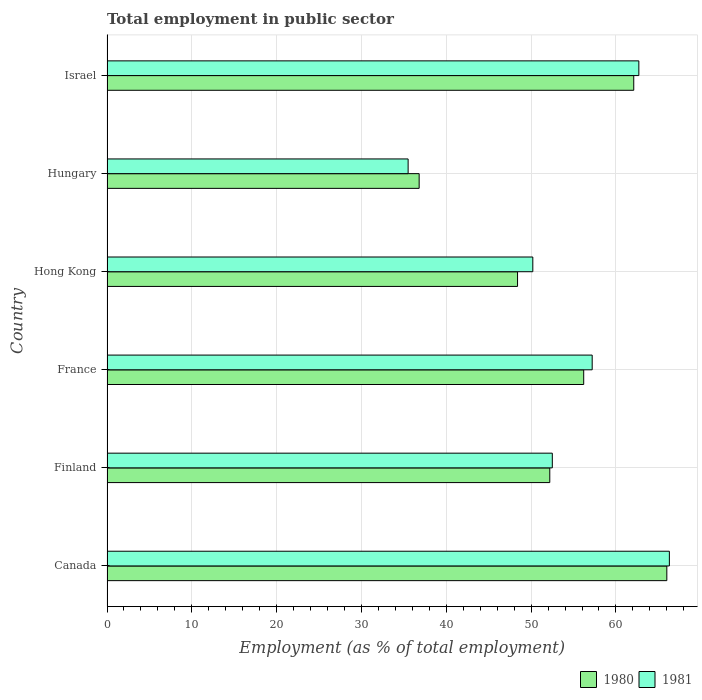How many groups of bars are there?
Provide a short and direct response. 6. How many bars are there on the 4th tick from the top?
Provide a short and direct response. 2. What is the label of the 4th group of bars from the top?
Give a very brief answer. France. What is the employment in public sector in 1980 in Hungary?
Your answer should be compact. 36.8. Across all countries, what is the maximum employment in public sector in 1981?
Keep it short and to the point. 66.3. Across all countries, what is the minimum employment in public sector in 1981?
Provide a succinct answer. 35.5. In which country was the employment in public sector in 1981 minimum?
Your response must be concise. Hungary. What is the total employment in public sector in 1980 in the graph?
Make the answer very short. 321.7. What is the difference between the employment in public sector in 1980 in Canada and that in Hong Kong?
Give a very brief answer. 17.6. What is the difference between the employment in public sector in 1981 in Finland and the employment in public sector in 1980 in Israel?
Make the answer very short. -9.6. What is the average employment in public sector in 1981 per country?
Your answer should be compact. 54.07. What is the difference between the employment in public sector in 1980 and employment in public sector in 1981 in Israel?
Your response must be concise. -0.6. In how many countries, is the employment in public sector in 1980 greater than 50 %?
Provide a succinct answer. 4. What is the ratio of the employment in public sector in 1980 in France to that in Israel?
Your answer should be very brief. 0.9. Is the difference between the employment in public sector in 1980 in Canada and Hungary greater than the difference between the employment in public sector in 1981 in Canada and Hungary?
Offer a terse response. No. What is the difference between the highest and the second highest employment in public sector in 1981?
Your answer should be compact. 3.6. What is the difference between the highest and the lowest employment in public sector in 1980?
Your response must be concise. 29.2. How many bars are there?
Provide a succinct answer. 12. How many countries are there in the graph?
Provide a succinct answer. 6. What is the difference between two consecutive major ticks on the X-axis?
Your answer should be compact. 10. Does the graph contain any zero values?
Your answer should be compact. No. Where does the legend appear in the graph?
Your answer should be very brief. Bottom right. What is the title of the graph?
Provide a short and direct response. Total employment in public sector. Does "1965" appear as one of the legend labels in the graph?
Your answer should be compact. No. What is the label or title of the X-axis?
Your response must be concise. Employment (as % of total employment). What is the label or title of the Y-axis?
Keep it short and to the point. Country. What is the Employment (as % of total employment) in 1981 in Canada?
Give a very brief answer. 66.3. What is the Employment (as % of total employment) in 1980 in Finland?
Provide a succinct answer. 52.2. What is the Employment (as % of total employment) in 1981 in Finland?
Keep it short and to the point. 52.5. What is the Employment (as % of total employment) of 1980 in France?
Make the answer very short. 56.2. What is the Employment (as % of total employment) of 1981 in France?
Offer a very short reply. 57.2. What is the Employment (as % of total employment) in 1980 in Hong Kong?
Offer a very short reply. 48.4. What is the Employment (as % of total employment) in 1981 in Hong Kong?
Ensure brevity in your answer.  50.2. What is the Employment (as % of total employment) of 1980 in Hungary?
Keep it short and to the point. 36.8. What is the Employment (as % of total employment) of 1981 in Hungary?
Your answer should be very brief. 35.5. What is the Employment (as % of total employment) in 1980 in Israel?
Provide a short and direct response. 62.1. What is the Employment (as % of total employment) in 1981 in Israel?
Provide a short and direct response. 62.7. Across all countries, what is the maximum Employment (as % of total employment) of 1981?
Your response must be concise. 66.3. Across all countries, what is the minimum Employment (as % of total employment) of 1980?
Make the answer very short. 36.8. Across all countries, what is the minimum Employment (as % of total employment) of 1981?
Your answer should be compact. 35.5. What is the total Employment (as % of total employment) of 1980 in the graph?
Provide a succinct answer. 321.7. What is the total Employment (as % of total employment) in 1981 in the graph?
Offer a terse response. 324.4. What is the difference between the Employment (as % of total employment) in 1981 in Canada and that in Finland?
Provide a succinct answer. 13.8. What is the difference between the Employment (as % of total employment) of 1980 in Canada and that in France?
Provide a short and direct response. 9.8. What is the difference between the Employment (as % of total employment) in 1980 in Canada and that in Hungary?
Provide a succinct answer. 29.2. What is the difference between the Employment (as % of total employment) in 1981 in Canada and that in Hungary?
Your answer should be very brief. 30.8. What is the difference between the Employment (as % of total employment) of 1981 in Finland and that in France?
Give a very brief answer. -4.7. What is the difference between the Employment (as % of total employment) of 1980 in Finland and that in Hong Kong?
Make the answer very short. 3.8. What is the difference between the Employment (as % of total employment) of 1981 in Finland and that in Hungary?
Your response must be concise. 17. What is the difference between the Employment (as % of total employment) of 1981 in France and that in Hong Kong?
Offer a terse response. 7. What is the difference between the Employment (as % of total employment) of 1980 in France and that in Hungary?
Give a very brief answer. 19.4. What is the difference between the Employment (as % of total employment) of 1981 in France and that in Hungary?
Your answer should be very brief. 21.7. What is the difference between the Employment (as % of total employment) in 1980 in Hong Kong and that in Israel?
Ensure brevity in your answer.  -13.7. What is the difference between the Employment (as % of total employment) of 1980 in Hungary and that in Israel?
Offer a very short reply. -25.3. What is the difference between the Employment (as % of total employment) in 1981 in Hungary and that in Israel?
Your answer should be very brief. -27.2. What is the difference between the Employment (as % of total employment) of 1980 in Canada and the Employment (as % of total employment) of 1981 in Finland?
Provide a succinct answer. 13.5. What is the difference between the Employment (as % of total employment) of 1980 in Canada and the Employment (as % of total employment) of 1981 in Hong Kong?
Offer a terse response. 15.8. What is the difference between the Employment (as % of total employment) of 1980 in Canada and the Employment (as % of total employment) of 1981 in Hungary?
Offer a terse response. 30.5. What is the difference between the Employment (as % of total employment) of 1980 in Canada and the Employment (as % of total employment) of 1981 in Israel?
Keep it short and to the point. 3.3. What is the difference between the Employment (as % of total employment) of 1980 in Finland and the Employment (as % of total employment) of 1981 in Hungary?
Give a very brief answer. 16.7. What is the difference between the Employment (as % of total employment) in 1980 in Finland and the Employment (as % of total employment) in 1981 in Israel?
Provide a succinct answer. -10.5. What is the difference between the Employment (as % of total employment) in 1980 in France and the Employment (as % of total employment) in 1981 in Hong Kong?
Ensure brevity in your answer.  6. What is the difference between the Employment (as % of total employment) in 1980 in France and the Employment (as % of total employment) in 1981 in Hungary?
Your response must be concise. 20.7. What is the difference between the Employment (as % of total employment) in 1980 in Hong Kong and the Employment (as % of total employment) in 1981 in Israel?
Your answer should be very brief. -14.3. What is the difference between the Employment (as % of total employment) in 1980 in Hungary and the Employment (as % of total employment) in 1981 in Israel?
Your answer should be compact. -25.9. What is the average Employment (as % of total employment) in 1980 per country?
Your answer should be compact. 53.62. What is the average Employment (as % of total employment) of 1981 per country?
Your response must be concise. 54.07. What is the difference between the Employment (as % of total employment) in 1980 and Employment (as % of total employment) in 1981 in Canada?
Make the answer very short. -0.3. What is the difference between the Employment (as % of total employment) of 1980 and Employment (as % of total employment) of 1981 in France?
Offer a terse response. -1. What is the difference between the Employment (as % of total employment) in 1980 and Employment (as % of total employment) in 1981 in Hong Kong?
Provide a short and direct response. -1.8. What is the ratio of the Employment (as % of total employment) of 1980 in Canada to that in Finland?
Give a very brief answer. 1.26. What is the ratio of the Employment (as % of total employment) in 1981 in Canada to that in Finland?
Ensure brevity in your answer.  1.26. What is the ratio of the Employment (as % of total employment) of 1980 in Canada to that in France?
Your answer should be very brief. 1.17. What is the ratio of the Employment (as % of total employment) in 1981 in Canada to that in France?
Make the answer very short. 1.16. What is the ratio of the Employment (as % of total employment) of 1980 in Canada to that in Hong Kong?
Your answer should be compact. 1.36. What is the ratio of the Employment (as % of total employment) of 1981 in Canada to that in Hong Kong?
Offer a terse response. 1.32. What is the ratio of the Employment (as % of total employment) of 1980 in Canada to that in Hungary?
Ensure brevity in your answer.  1.79. What is the ratio of the Employment (as % of total employment) in 1981 in Canada to that in Hungary?
Offer a terse response. 1.87. What is the ratio of the Employment (as % of total employment) of 1980 in Canada to that in Israel?
Make the answer very short. 1.06. What is the ratio of the Employment (as % of total employment) of 1981 in Canada to that in Israel?
Provide a succinct answer. 1.06. What is the ratio of the Employment (as % of total employment) of 1980 in Finland to that in France?
Keep it short and to the point. 0.93. What is the ratio of the Employment (as % of total employment) of 1981 in Finland to that in France?
Your answer should be very brief. 0.92. What is the ratio of the Employment (as % of total employment) in 1980 in Finland to that in Hong Kong?
Your answer should be compact. 1.08. What is the ratio of the Employment (as % of total employment) of 1981 in Finland to that in Hong Kong?
Offer a terse response. 1.05. What is the ratio of the Employment (as % of total employment) in 1980 in Finland to that in Hungary?
Make the answer very short. 1.42. What is the ratio of the Employment (as % of total employment) in 1981 in Finland to that in Hungary?
Offer a terse response. 1.48. What is the ratio of the Employment (as % of total employment) in 1980 in Finland to that in Israel?
Keep it short and to the point. 0.84. What is the ratio of the Employment (as % of total employment) of 1981 in Finland to that in Israel?
Ensure brevity in your answer.  0.84. What is the ratio of the Employment (as % of total employment) of 1980 in France to that in Hong Kong?
Make the answer very short. 1.16. What is the ratio of the Employment (as % of total employment) in 1981 in France to that in Hong Kong?
Give a very brief answer. 1.14. What is the ratio of the Employment (as % of total employment) in 1980 in France to that in Hungary?
Offer a very short reply. 1.53. What is the ratio of the Employment (as % of total employment) of 1981 in France to that in Hungary?
Provide a succinct answer. 1.61. What is the ratio of the Employment (as % of total employment) in 1980 in France to that in Israel?
Offer a very short reply. 0.91. What is the ratio of the Employment (as % of total employment) in 1981 in France to that in Israel?
Your response must be concise. 0.91. What is the ratio of the Employment (as % of total employment) in 1980 in Hong Kong to that in Hungary?
Ensure brevity in your answer.  1.32. What is the ratio of the Employment (as % of total employment) in 1981 in Hong Kong to that in Hungary?
Your answer should be compact. 1.41. What is the ratio of the Employment (as % of total employment) of 1980 in Hong Kong to that in Israel?
Your answer should be compact. 0.78. What is the ratio of the Employment (as % of total employment) in 1981 in Hong Kong to that in Israel?
Your response must be concise. 0.8. What is the ratio of the Employment (as % of total employment) in 1980 in Hungary to that in Israel?
Make the answer very short. 0.59. What is the ratio of the Employment (as % of total employment) in 1981 in Hungary to that in Israel?
Offer a terse response. 0.57. What is the difference between the highest and the second highest Employment (as % of total employment) in 1980?
Your response must be concise. 3.9. What is the difference between the highest and the second highest Employment (as % of total employment) of 1981?
Provide a succinct answer. 3.6. What is the difference between the highest and the lowest Employment (as % of total employment) in 1980?
Your answer should be compact. 29.2. What is the difference between the highest and the lowest Employment (as % of total employment) of 1981?
Offer a terse response. 30.8. 